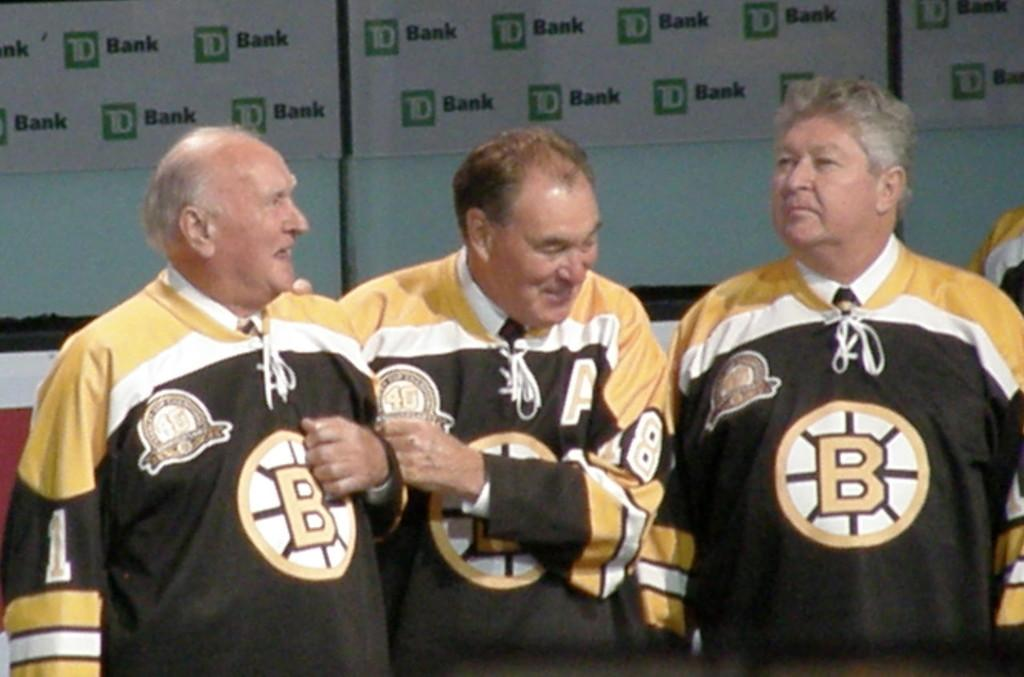<image>
Offer a succinct explanation of the picture presented. A group of men are all wearing matching jerseys in front of a wall with TD Bank signs. 